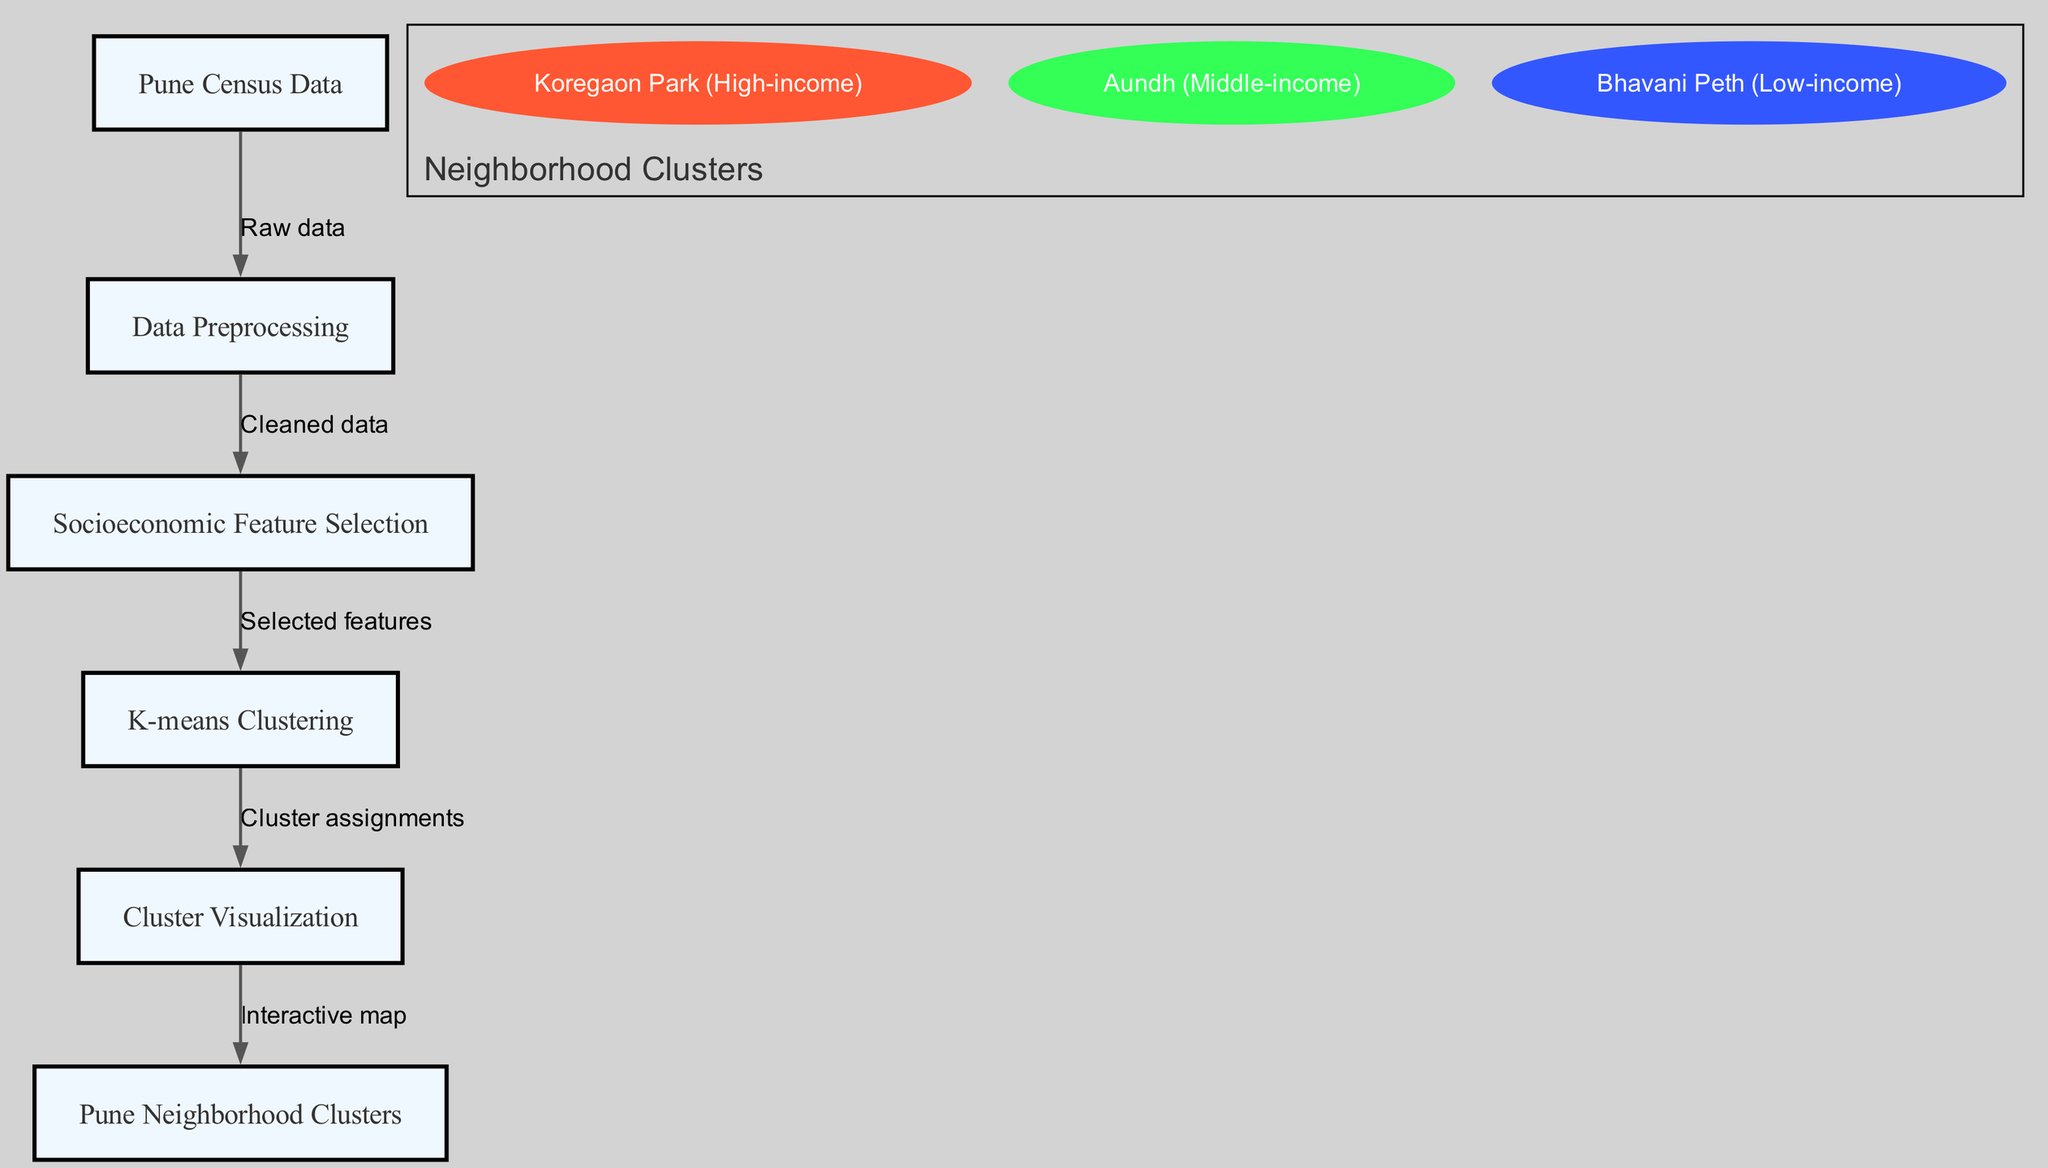What is the starting point of the analysis? The starting point of the analysis is the "Pune Census Data," as indicated by the first node in the diagram which serves as the raw data input for the entire clustering process.
Answer: Pune Census Data How many main processes are involved in the analysis? There are five main processes involved in the analysis as represented by the five nodes: input data, preprocessing, feature selection, clustering algorithm, and visualization.
Answer: Five What is the output of the clustering algorithm? The output of the clustering algorithm is the "Cluster assignments," which are represented in the diagram after the "K-means Clustering" step.
Answer: Cluster assignments Which neighborhood is classified as high-income? The neighborhood classified as high-income is "Koregaon Park," as indicated in the cluster information section of the diagram.
Answer: Koregaon Park What is the color representing Aundh in the clusters? The color representing Aundh in the clusters is green, which corresponds to its classification as a middle-income neighborhood within the visualization.
Answer: Green What type of visualization is used at the end of the analysis? The type of visualization used at the end of the analysis is an "Interactive map," which allows users to explore the neighborhood clusters visually.
Answer: Interactive map How is the cleaned data obtained in the process? The cleaned data is obtained from the "Data Preprocessing" step, which follows the "Pune Census Data" node, indicating a transformation of raw data into a more usable form for further analysis.
Answer: Cleaned data Which node directly connects to the visualization? The node that directly connects to the visualization is the "K-means Clustering" node, indicating that the clustering algorithm directly influences the visualization output.
Answer: K-means Clustering What connects feature selection to the clustering algorithm? The connection from feature selection to the clustering algorithm is labeled "Selected features," indicating that only certain features are chosen for clustering after the feature selection step.
Answer: Selected features 